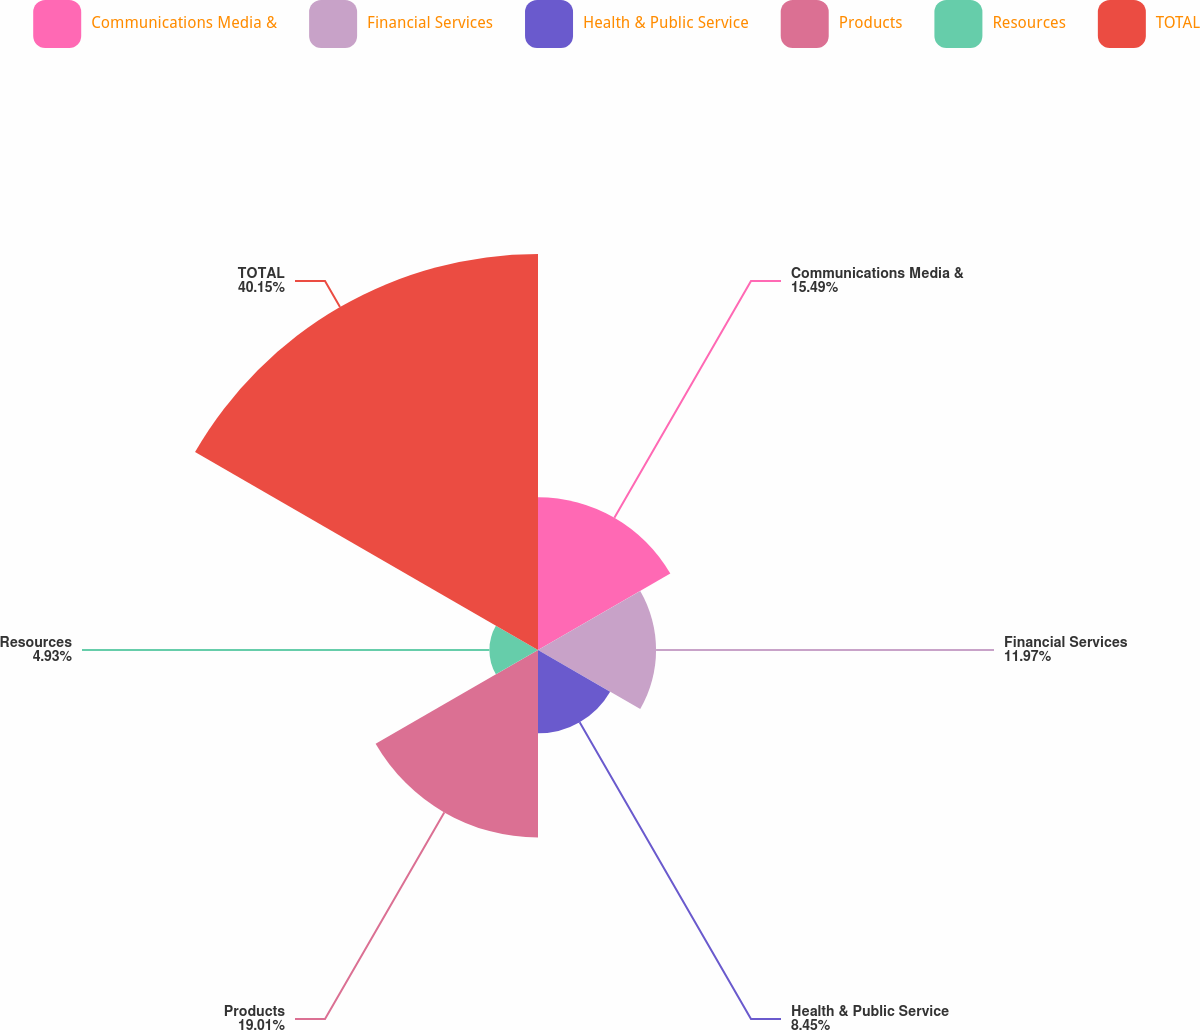Convert chart to OTSL. <chart><loc_0><loc_0><loc_500><loc_500><pie_chart><fcel>Communications Media &<fcel>Financial Services<fcel>Health & Public Service<fcel>Products<fcel>Resources<fcel>TOTAL<nl><fcel>15.49%<fcel>11.97%<fcel>8.45%<fcel>19.01%<fcel>4.93%<fcel>40.15%<nl></chart> 